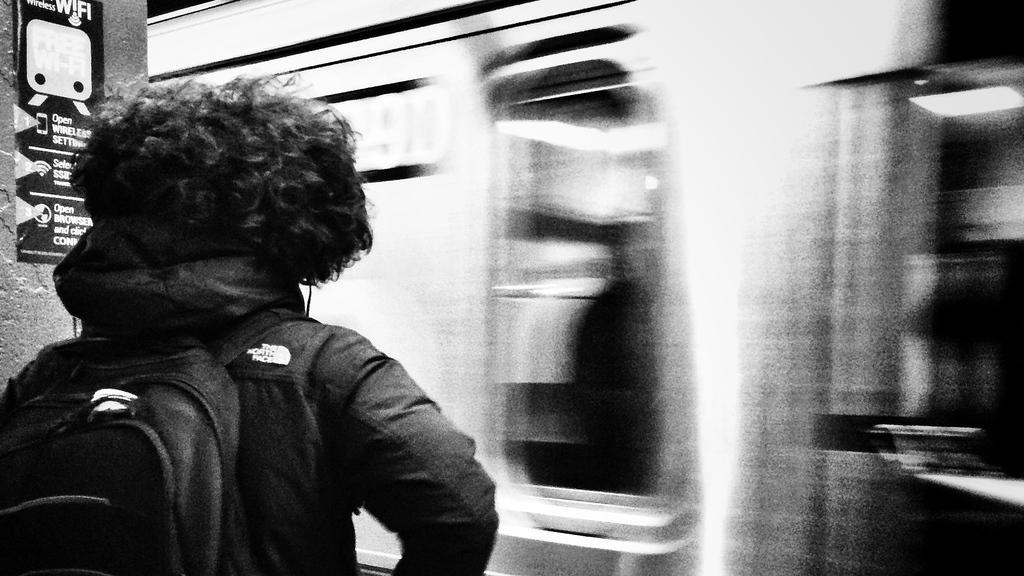In one or two sentences, can you explain what this image depicts? In this image I can see on the left side a man is there, he wore coat, bag. On the right side it looks like a train is moving. 